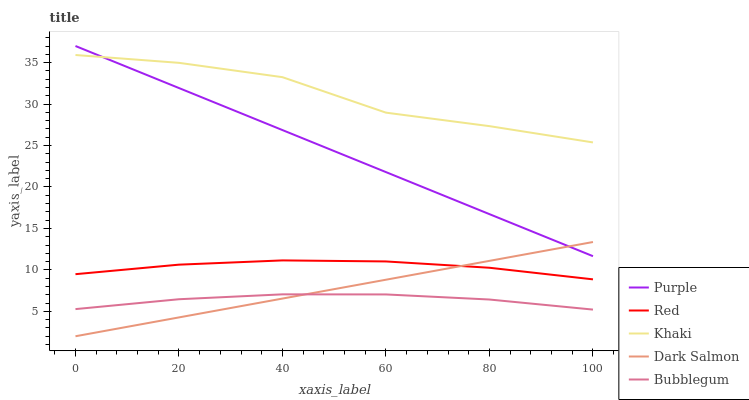Does Bubblegum have the minimum area under the curve?
Answer yes or no. Yes. Does Khaki have the maximum area under the curve?
Answer yes or no. Yes. Does Khaki have the minimum area under the curve?
Answer yes or no. No. Does Bubblegum have the maximum area under the curve?
Answer yes or no. No. Is Dark Salmon the smoothest?
Answer yes or no. Yes. Is Khaki the roughest?
Answer yes or no. Yes. Is Bubblegum the smoothest?
Answer yes or no. No. Is Bubblegum the roughest?
Answer yes or no. No. Does Bubblegum have the lowest value?
Answer yes or no. No. Does Purple have the highest value?
Answer yes or no. Yes. Does Khaki have the highest value?
Answer yes or no. No. Is Bubblegum less than Khaki?
Answer yes or no. Yes. Is Red greater than Bubblegum?
Answer yes or no. Yes. Does Purple intersect Dark Salmon?
Answer yes or no. Yes. Is Purple less than Dark Salmon?
Answer yes or no. No. Is Purple greater than Dark Salmon?
Answer yes or no. No. Does Bubblegum intersect Khaki?
Answer yes or no. No. 